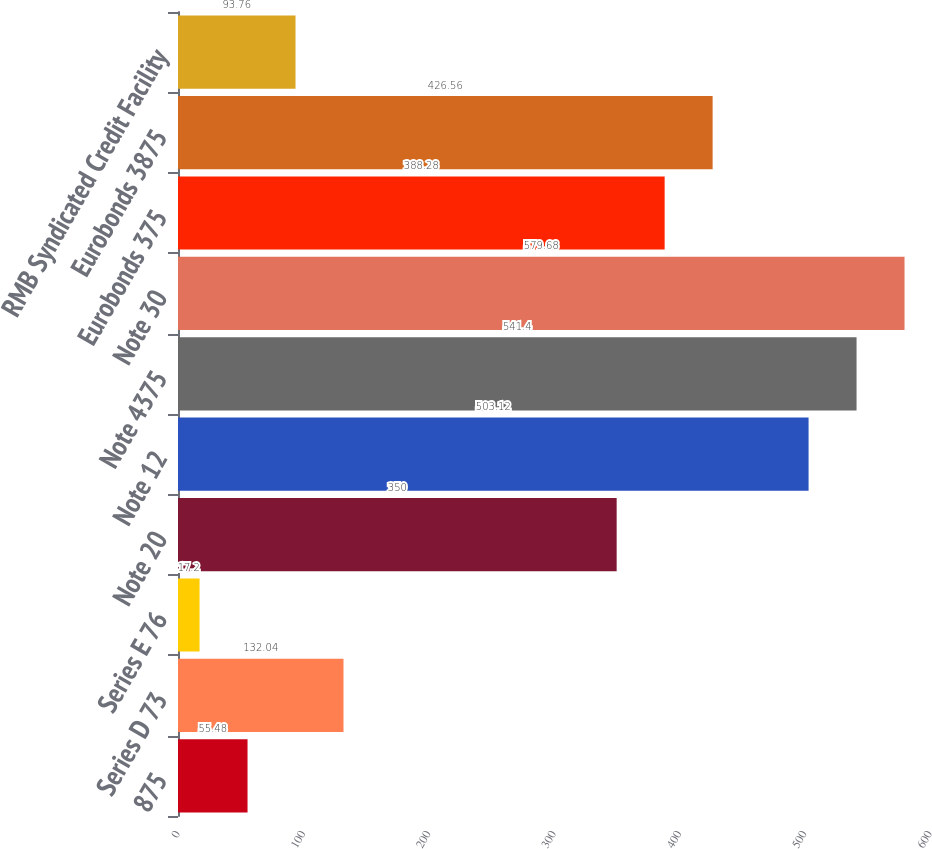Convert chart. <chart><loc_0><loc_0><loc_500><loc_500><bar_chart><fcel>875<fcel>Series D 73<fcel>Series E 76<fcel>Note 20<fcel>Note 12<fcel>Note 4375<fcel>Note 30<fcel>Eurobonds 375<fcel>Eurobonds 3875<fcel>RMB Syndicated Credit Facility<nl><fcel>55.48<fcel>132.04<fcel>17.2<fcel>350<fcel>503.12<fcel>541.4<fcel>579.68<fcel>388.28<fcel>426.56<fcel>93.76<nl></chart> 